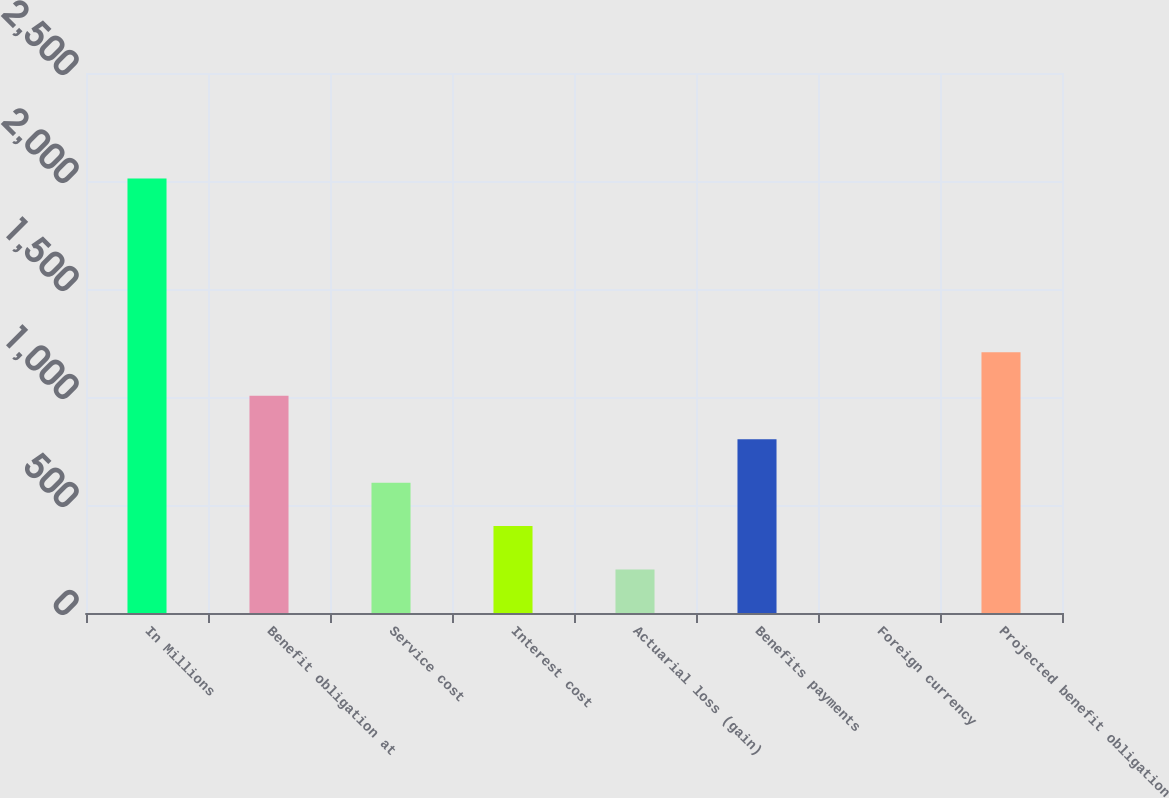Convert chart. <chart><loc_0><loc_0><loc_500><loc_500><bar_chart><fcel>In Millions<fcel>Benefit obligation at<fcel>Service cost<fcel>Interest cost<fcel>Actuarial loss (gain)<fcel>Benefits payments<fcel>Foreign currency<fcel>Projected benefit obligation<nl><fcel>2011<fcel>1005.65<fcel>603.51<fcel>402.44<fcel>201.37<fcel>804.58<fcel>0.3<fcel>1206.72<nl></chart> 